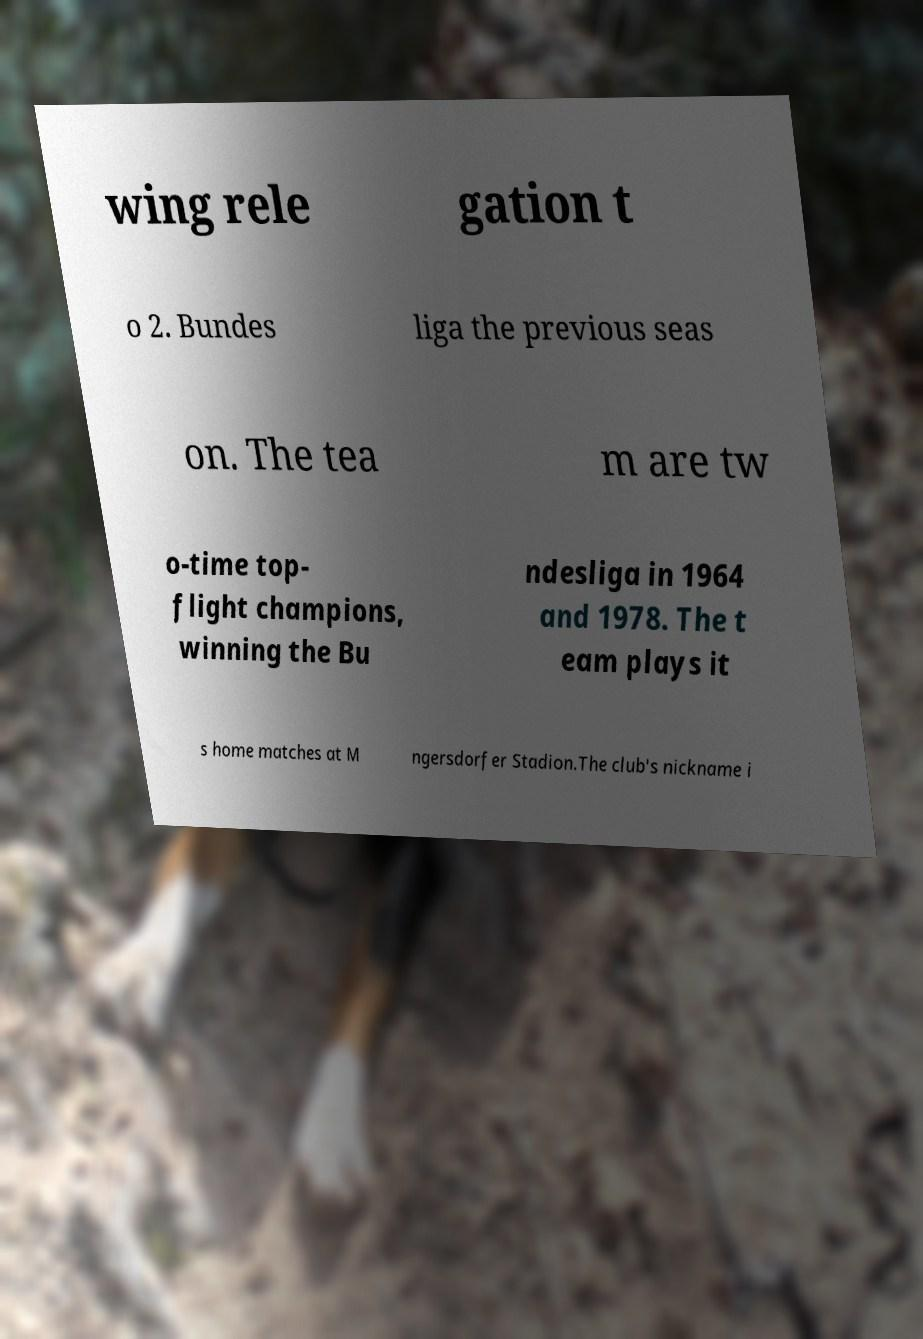There's text embedded in this image that I need extracted. Can you transcribe it verbatim? wing rele gation t o 2. Bundes liga the previous seas on. The tea m are tw o-time top- flight champions, winning the Bu ndesliga in 1964 and 1978. The t eam plays it s home matches at M ngersdorfer Stadion.The club's nickname i 